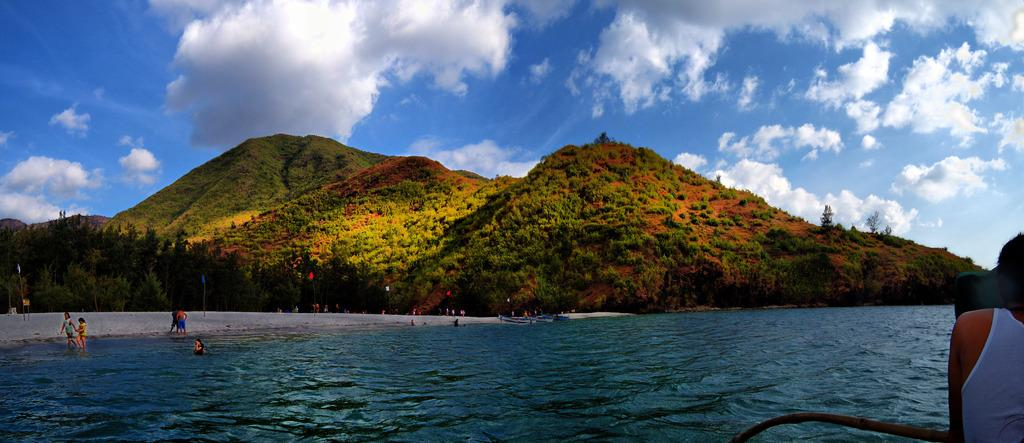What is one of the natural elements present in the image? There is water in the image. What type of vegetation can be seen in the image? There are trees in the image. What man-made objects are visible in the image? There are flags in the image. What can be seen in the sky in the image? Clouds and the sky are visible in the image. Who or what is present in the image? There are people in the image. Is there a bone visible in the image? No, there is no bone present in the image. Can you see a cemetery in the image? No, there is no cemetery present in the image. 